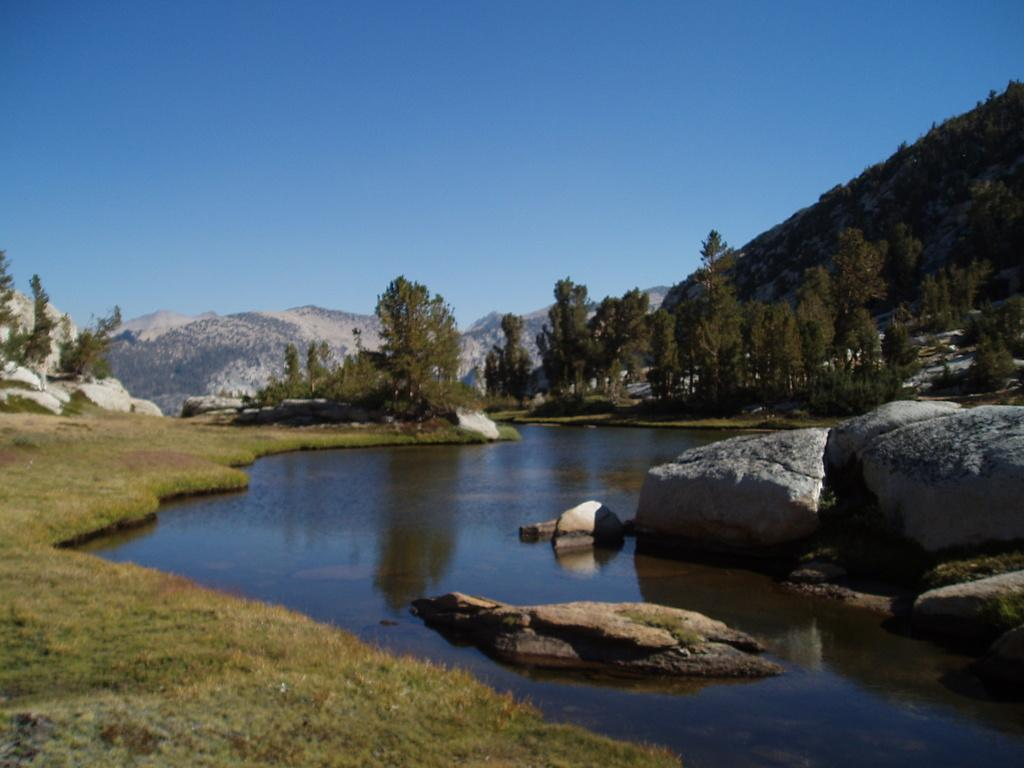What is in the foreground of the image? There is water, stones, and grass in the foreground of the image. What can be seen in the background of the image? There are trees and mountains in the background of the image. What is visible at the top of the image? The sky is visible at the top of the image. Can you tell me how many turkeys are perched on the mountains in the image? There are no turkeys present in the image; it features water, stones, grass, trees, mountains, and the sky. What type of bean is growing on the grass in the image? There are no beans present in the image; it features water, stones, grass, trees, mountains, and the sky. 